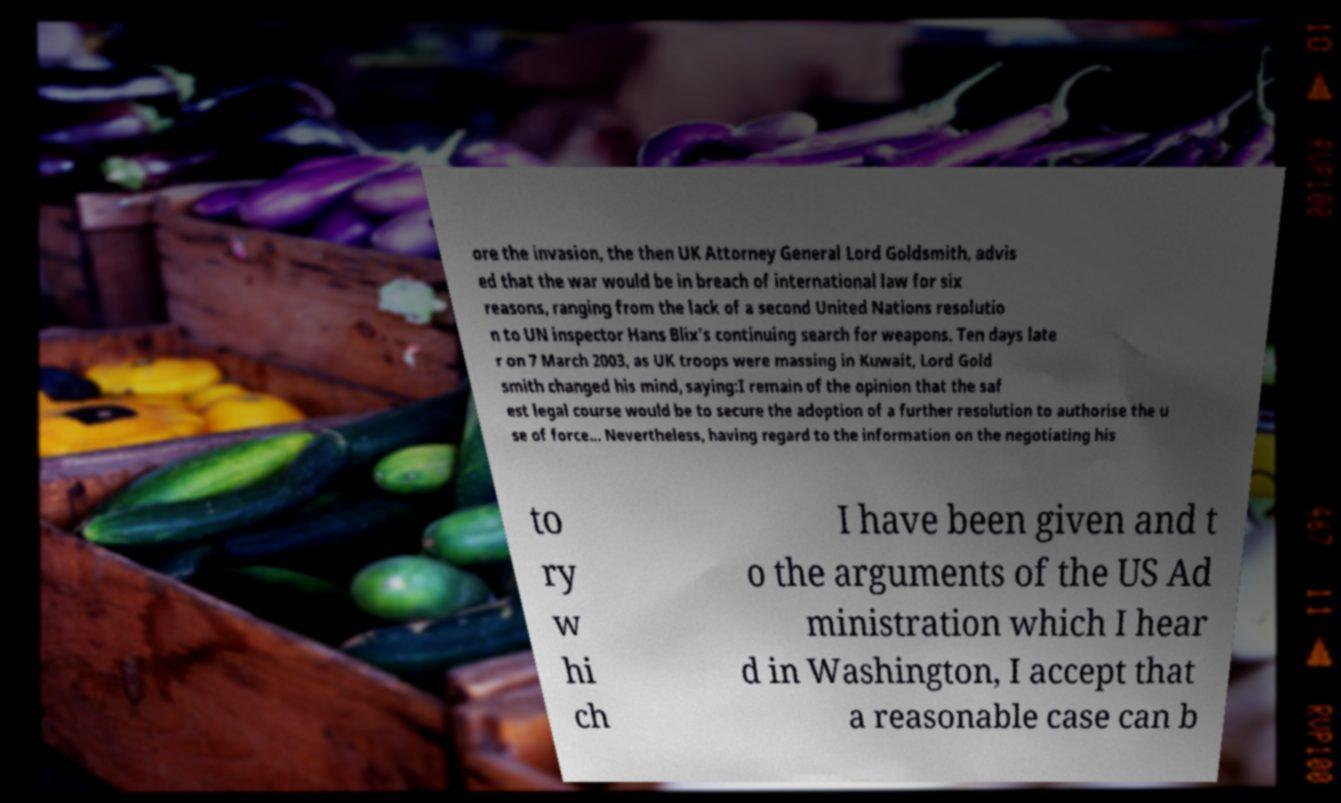What messages or text are displayed in this image? I need them in a readable, typed format. ore the invasion, the then UK Attorney General Lord Goldsmith, advis ed that the war would be in breach of international law for six reasons, ranging from the lack of a second United Nations resolutio n to UN inspector Hans Blix's continuing search for weapons. Ten days late r on 7 March 2003, as UK troops were massing in Kuwait, Lord Gold smith changed his mind, saying:I remain of the opinion that the saf est legal course would be to secure the adoption of a further resolution to authorise the u se of force... Nevertheless, having regard to the information on the negotiating his to ry w hi ch I have been given and t o the arguments of the US Ad ministration which I hear d in Washington, I accept that a reasonable case can b 